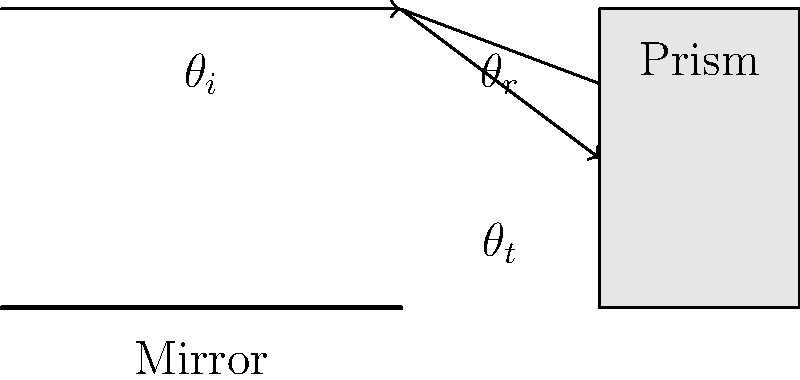In makeup application, understanding light behavior is crucial. Consider a setup where light reflects off a mirror and then passes through a prism-like substance (e.g., a highlighter). If the angle of incidence ($\theta_i$) is 30°, and the refractive index of the prism is 1.5, calculate the angle of refraction ($\theta_t$) as the light enters the prism. Assume the refractive index of air is 1.0. To solve this problem, we'll use Snell's law and the law of reflection. Let's break it down step-by-step:

1. Law of Reflection: The angle of incidence equals the angle of reflection.
   $\theta_i = \theta_r = 30°$

2. Snell's Law: $n_1 \sin(\theta_1) = n_2 \sin(\theta_2)$
   Where $n_1$ and $n_2$ are the refractive indices of the two media, and $\theta_1$ and $\theta_2$ are the angles of incidence and refraction, respectively.

3. In this case:
   $n_1 = 1.0$ (air)
   $n_2 = 1.5$ (prism/highlighter)
   $\theta_1 = \theta_r = 30°$ (angle of reflection = angle of incidence)
   $\theta_2 = \theta_t$ (angle of refraction, which we need to find)

4. Substituting into Snell's law:
   $1.0 \sin(30°) = 1.5 \sin(\theta_t)$

5. Solving for $\theta_t$:
   $\sin(\theta_t) = \frac{1.0 \sin(30°)}{1.5}$
   $\sin(\theta_t) = \frac{0.5}{1.5} = \frac{1}{3}$

6. Taking the inverse sine (arcsin) of both sides:
   $\theta_t = \arcsin(\frac{1}{3}) \approx 19.47°$

This result shows how light bends when entering a substance with a higher refractive index, which is relevant to understanding how light interacts with different makeup products and skin surfaces.
Answer: $19.47°$ 